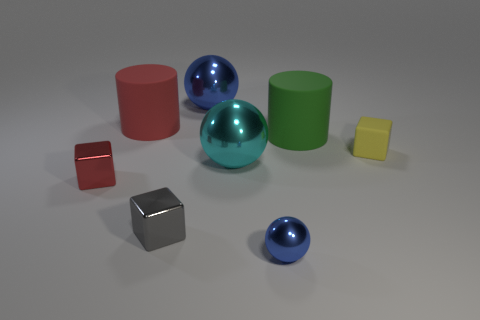Subtract 1 balls. How many balls are left? 2 Add 1 big cylinders. How many objects exist? 9 Subtract all spheres. How many objects are left? 5 Add 1 red matte cylinders. How many red matte cylinders exist? 2 Subtract 1 red cubes. How many objects are left? 7 Subtract all tiny cyan blocks. Subtract all blue spheres. How many objects are left? 6 Add 4 green matte cylinders. How many green matte cylinders are left? 5 